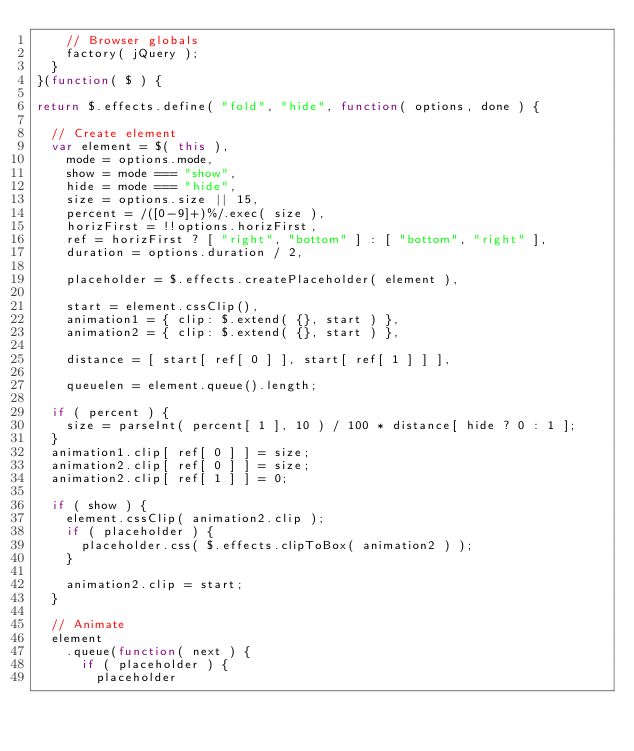Convert code to text. <code><loc_0><loc_0><loc_500><loc_500><_JavaScript_>		// Browser globals
		factory( jQuery );
	}
}(function( $ ) {

return $.effects.define( "fold", "hide", function( options, done ) {

	// Create element
	var element = $( this ),
		mode = options.mode,
		show = mode === "show",
		hide = mode === "hide",
		size = options.size || 15,
		percent = /([0-9]+)%/.exec( size ),
		horizFirst = !!options.horizFirst,
		ref = horizFirst ? [ "right", "bottom" ] : [ "bottom", "right" ],
		duration = options.duration / 2,

		placeholder = $.effects.createPlaceholder( element ),

		start = element.cssClip(),
		animation1 = { clip: $.extend( {}, start ) },
		animation2 = { clip: $.extend( {}, start ) },

		distance = [ start[ ref[ 0 ] ], start[ ref[ 1 ] ] ],

		queuelen = element.queue().length;

	if ( percent ) {
		size = parseInt( percent[ 1 ], 10 ) / 100 * distance[ hide ? 0 : 1 ];
	}
	animation1.clip[ ref[ 0 ] ] = size;
	animation2.clip[ ref[ 0 ] ] = size;
	animation2.clip[ ref[ 1 ] ] = 0;

	if ( show ) {
		element.cssClip( animation2.clip );
		if ( placeholder ) {
			placeholder.css( $.effects.clipToBox( animation2 ) );
		}

		animation2.clip = start;
	}

	// Animate
	element
		.queue(function( next ) {
			if ( placeholder ) {
				placeholder</code> 